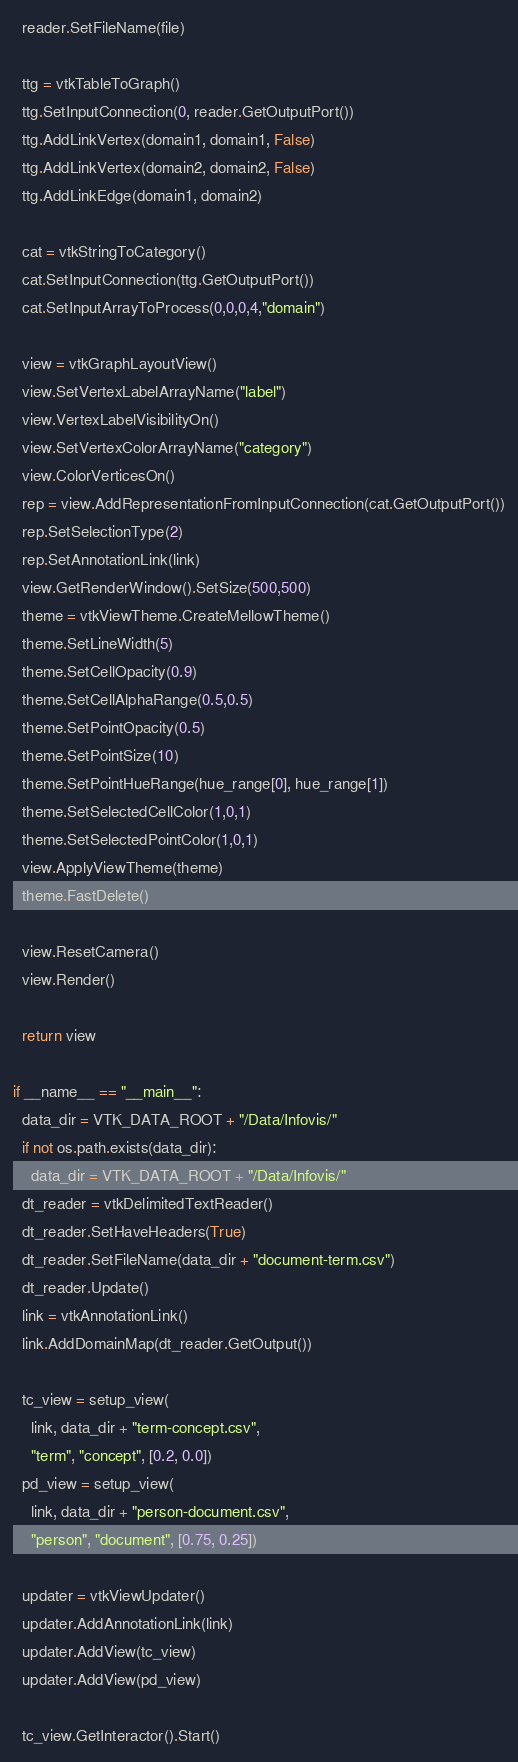<code> <loc_0><loc_0><loc_500><loc_500><_Python_>  reader.SetFileName(file)

  ttg = vtkTableToGraph()
  ttg.SetInputConnection(0, reader.GetOutputPort())
  ttg.AddLinkVertex(domain1, domain1, False)
  ttg.AddLinkVertex(domain2, domain2, False)
  ttg.AddLinkEdge(domain1, domain2)

  cat = vtkStringToCategory()
  cat.SetInputConnection(ttg.GetOutputPort())
  cat.SetInputArrayToProcess(0,0,0,4,"domain")

  view = vtkGraphLayoutView()
  view.SetVertexLabelArrayName("label")
  view.VertexLabelVisibilityOn()
  view.SetVertexColorArrayName("category")
  view.ColorVerticesOn()
  rep = view.AddRepresentationFromInputConnection(cat.GetOutputPort())
  rep.SetSelectionType(2)
  rep.SetAnnotationLink(link)
  view.GetRenderWindow().SetSize(500,500)
  theme = vtkViewTheme.CreateMellowTheme()
  theme.SetLineWidth(5)
  theme.SetCellOpacity(0.9)
  theme.SetCellAlphaRange(0.5,0.5)
  theme.SetPointOpacity(0.5)
  theme.SetPointSize(10)
  theme.SetPointHueRange(hue_range[0], hue_range[1])
  theme.SetSelectedCellColor(1,0,1)
  theme.SetSelectedPointColor(1,0,1)
  view.ApplyViewTheme(theme)
  theme.FastDelete()

  view.ResetCamera()
  view.Render()

  return view

if __name__ == "__main__":
  data_dir = VTK_DATA_ROOT + "/Data/Infovis/"
  if not os.path.exists(data_dir):
    data_dir = VTK_DATA_ROOT + "/Data/Infovis/"
  dt_reader = vtkDelimitedTextReader()
  dt_reader.SetHaveHeaders(True)
  dt_reader.SetFileName(data_dir + "document-term.csv")
  dt_reader.Update()
  link = vtkAnnotationLink()
  link.AddDomainMap(dt_reader.GetOutput())

  tc_view = setup_view(
    link, data_dir + "term-concept.csv",
    "term", "concept", [0.2, 0.0])
  pd_view = setup_view(
    link, data_dir + "person-document.csv",
    "person", "document", [0.75, 0.25])

  updater = vtkViewUpdater()
  updater.AddAnnotationLink(link)
  updater.AddView(tc_view)
  updater.AddView(pd_view)

  tc_view.GetInteractor().Start()

</code> 